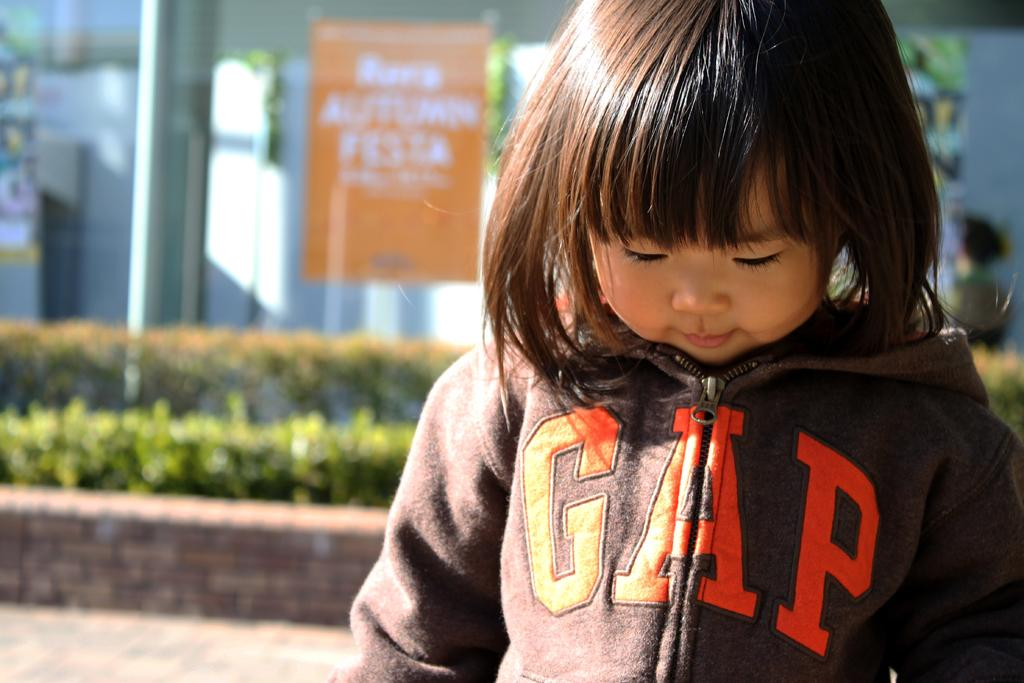Who is the main subject in the front of the image? There is a girl in the front of the image. What can be seen in the background of the image? There are plants and boards with text in the background of the image. Are there any other people visible in the image? Yes, there is a person in the background of the image. What type of goat can be seen rolling in the background of the image? There is no goat present in the image, and therefore no such activity can be observed. 